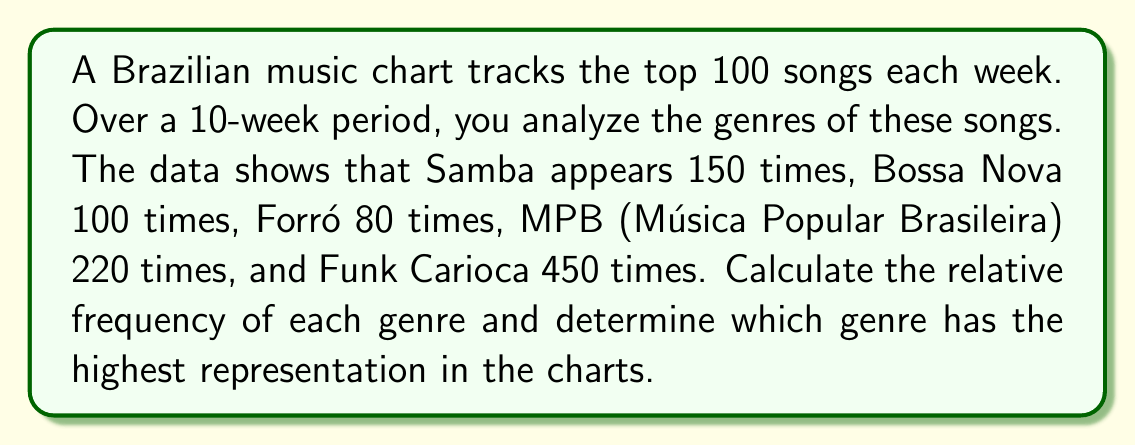Can you answer this question? To solve this problem, we need to follow these steps:

1. Calculate the total number of genre appearances:
   $$ \text{Total} = 150 + 100 + 80 + 220 + 450 = 1000 $$

2. Calculate the relative frequency for each genre using the formula:
   $$ \text{Relative Frequency} = \frac{\text{Genre Count}}{\text{Total Count}} $$

   For Samba: $\frac{150}{1000} = 0.15$ or 15%
   For Bossa Nova: $\frac{100}{1000} = 0.10$ or 10%
   For Forró: $\frac{80}{1000} = 0.08$ or 8%
   For MPB: $\frac{220}{1000} = 0.22$ or 22%
   For Funk Carioca: $\frac{450}{1000} = 0.45$ or 45%

3. Compare the relative frequencies to determine the highest:
   Funk Carioca has the highest relative frequency at 0.45 or 45%.
Answer: Funk Carioca (45%) 